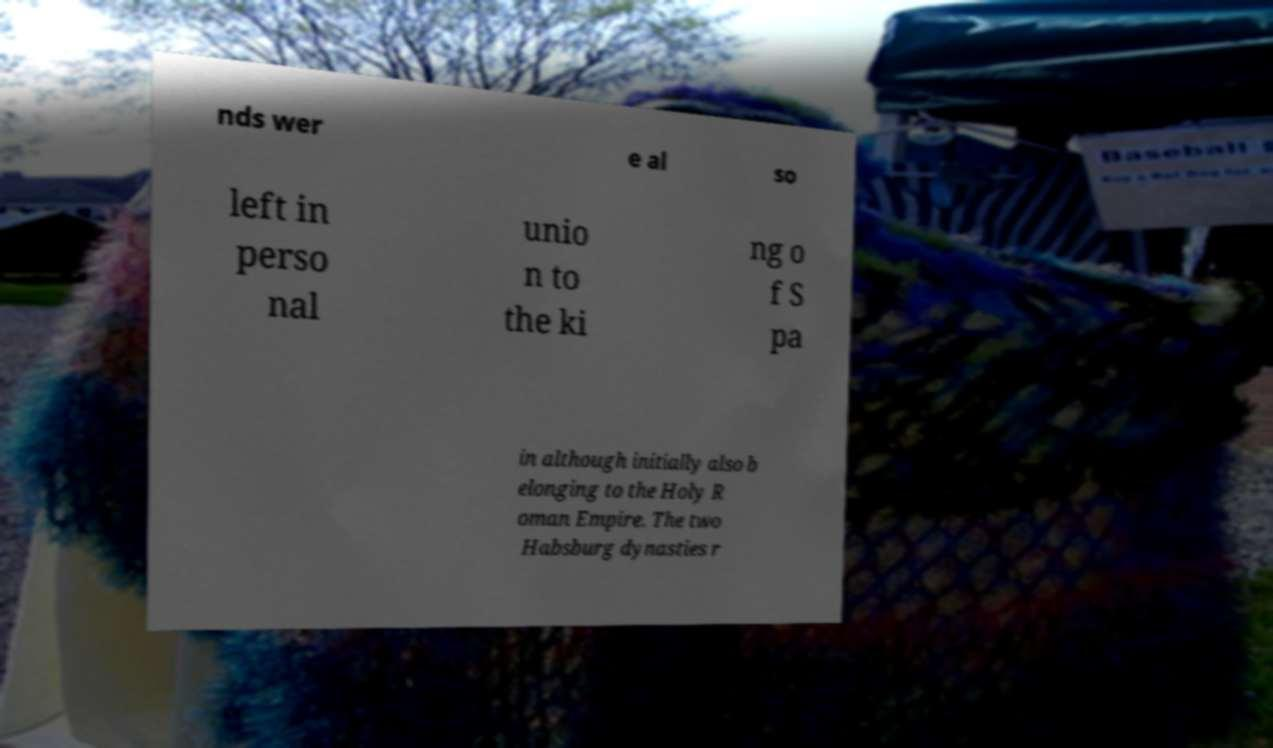Can you read and provide the text displayed in the image?This photo seems to have some interesting text. Can you extract and type it out for me? nds wer e al so left in perso nal unio n to the ki ng o f S pa in although initially also b elonging to the Holy R oman Empire. The two Habsburg dynasties r 